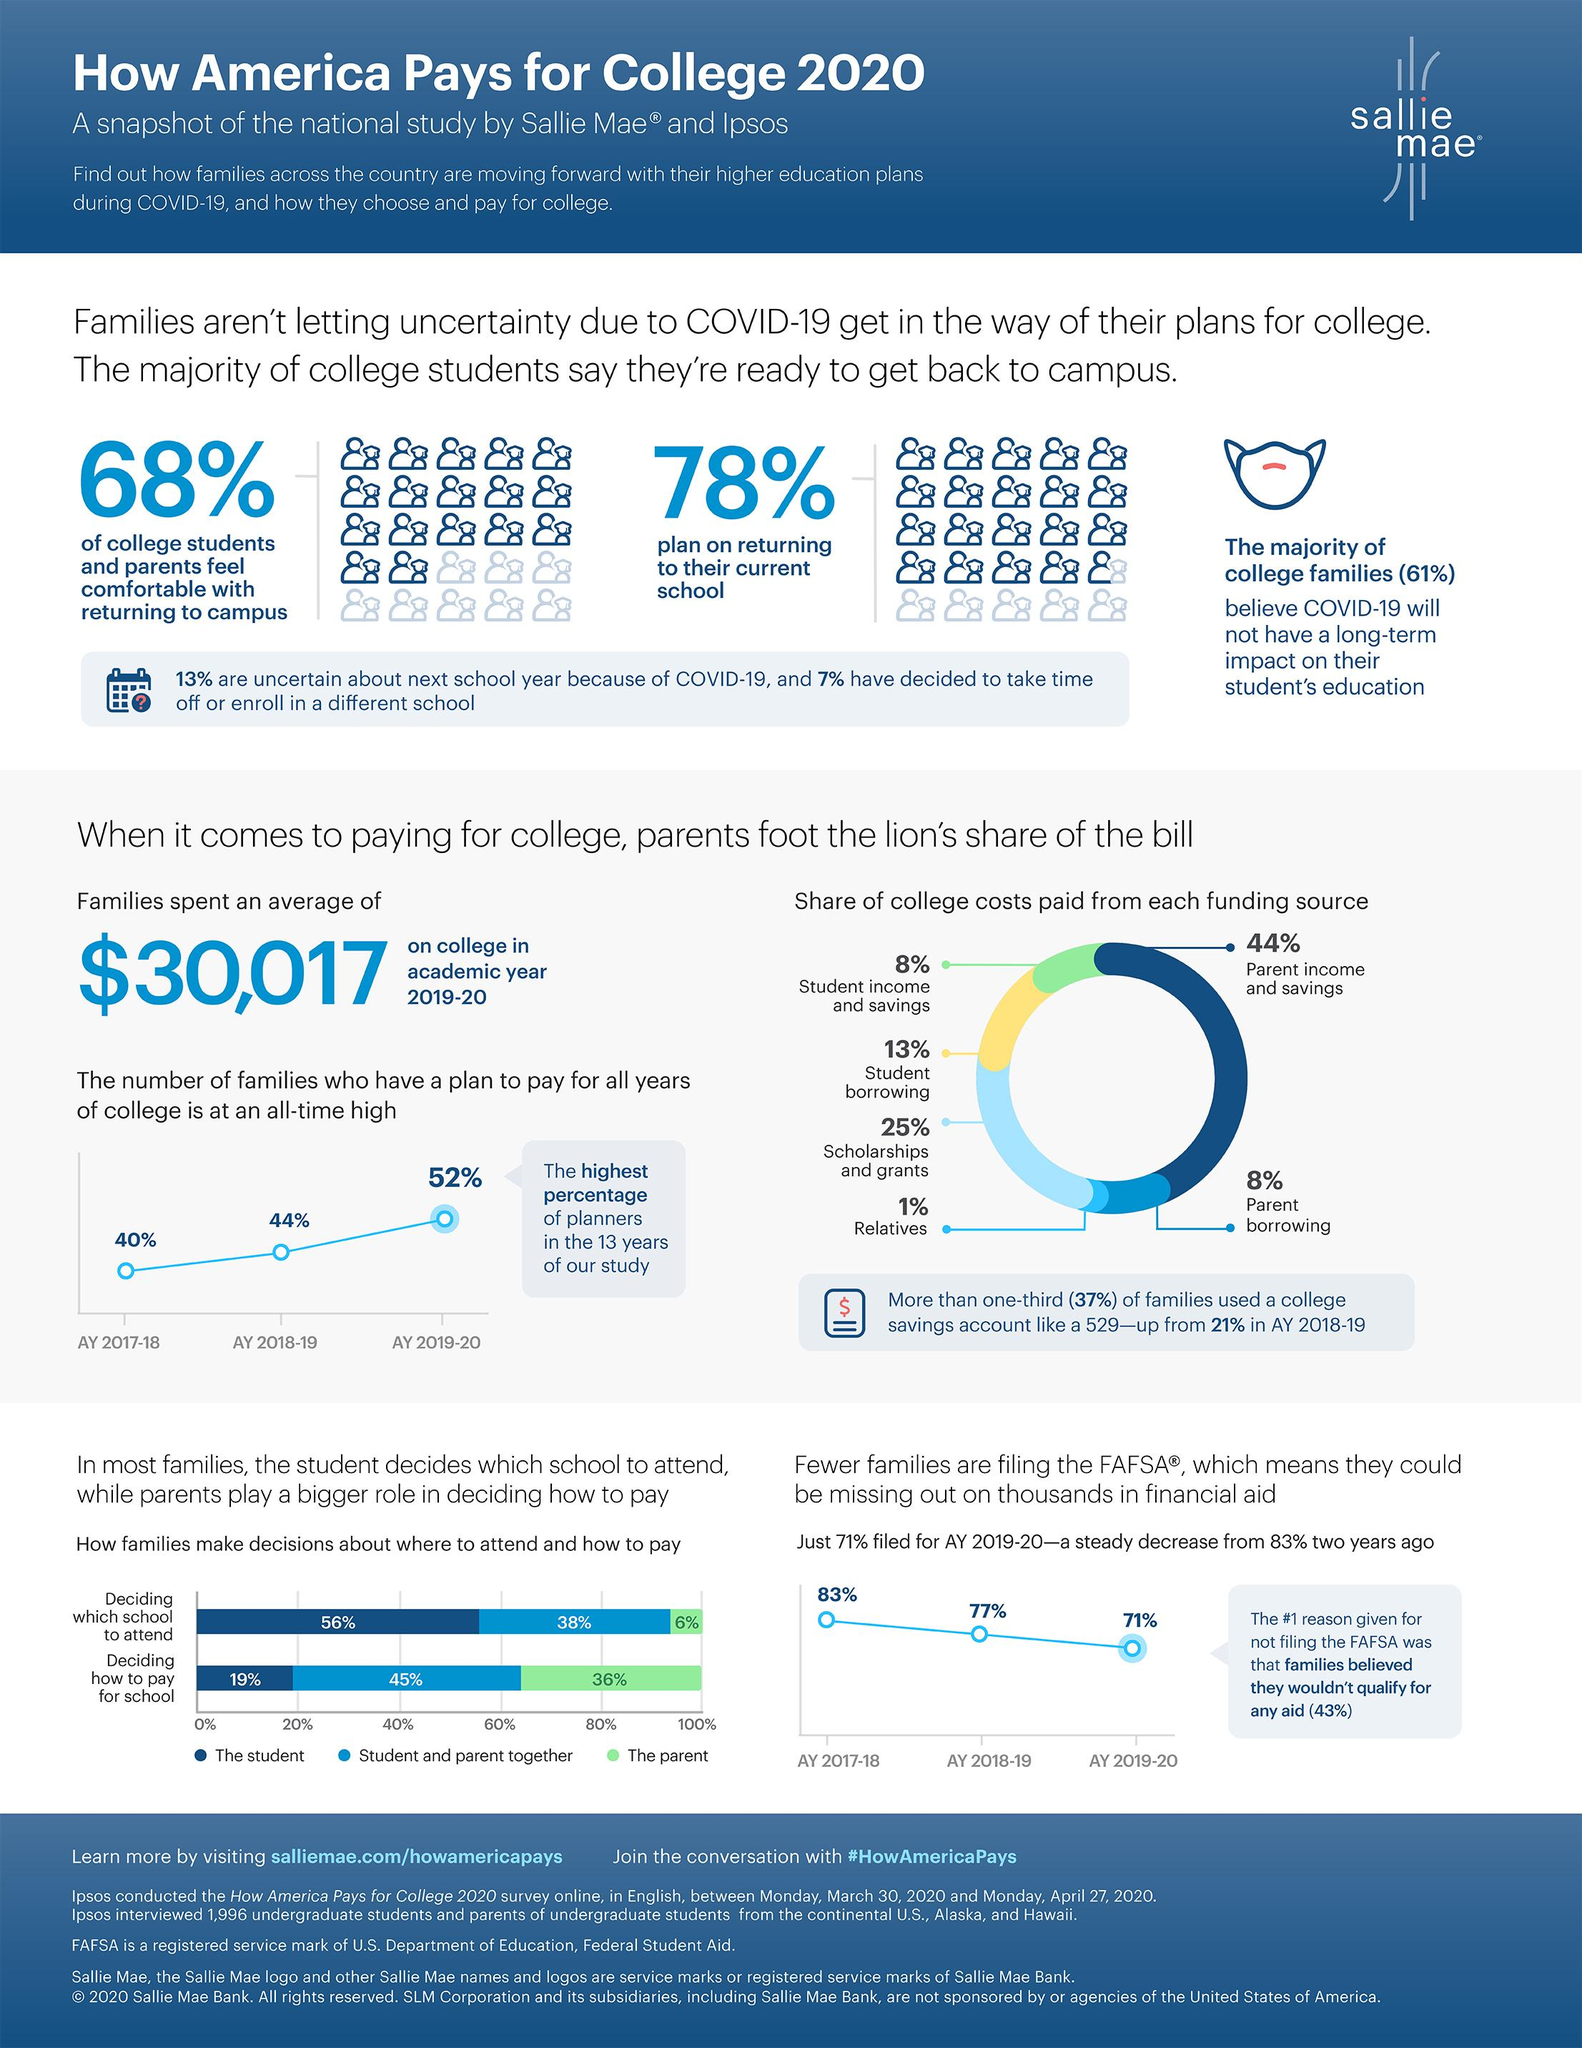Outline some significant characteristics in this image. The decision regarding which school to attend was made by both the parent and the student, with the parent contributing 38% to the decision-making process. Sixty percent of the decision regarding which school to attend is made solely by the parent. A significant majority of families involve the student in the decision-making process when it comes to choosing which school to attend. According to a recent survey, approximately 56% of college funds come from sources other than parental income and savings. According to recent data, the combined percentage of college funds from student income and parent borrowing is estimated to be 16%. 